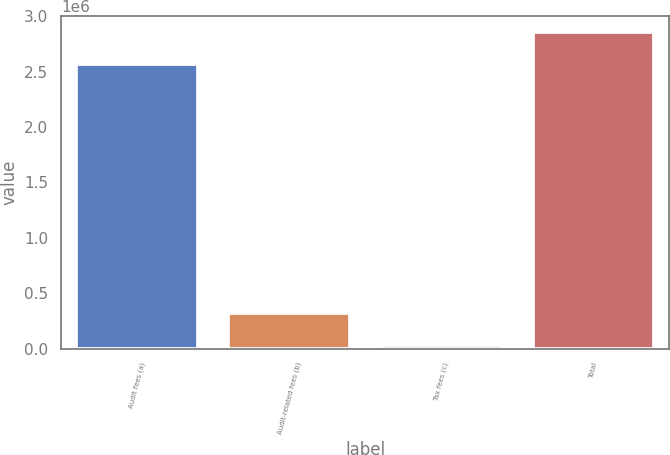Convert chart. <chart><loc_0><loc_0><loc_500><loc_500><bar_chart><fcel>Audit fees (a)<fcel>Audit-related fees (b)<fcel>Tax fees (c)<fcel>Total<nl><fcel>2.571e+06<fcel>319300<fcel>37000<fcel>2.86e+06<nl></chart> 